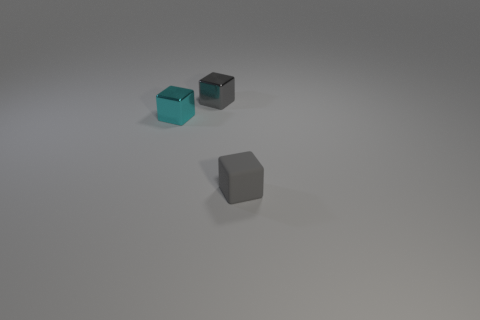There is a small metallic object that is the same color as the tiny matte object; what shape is it?
Ensure brevity in your answer.  Cube. What is the shape of the shiny object that is behind the small cyan thing?
Keep it short and to the point. Cube. What number of tiny cubes are both to the right of the tiny cyan cube and in front of the gray shiny object?
Provide a short and direct response. 1. There is a cyan metal thing; is its size the same as the metal object that is on the right side of the cyan thing?
Your response must be concise. Yes. There is a metallic cube behind the shiny block that is on the left side of the gray cube that is behind the matte object; how big is it?
Your response must be concise. Small. What is the size of the cube in front of the tiny cyan metal block?
Give a very brief answer. Small. There is a gray object that is the same material as the tiny cyan thing; what shape is it?
Your answer should be very brief. Cube. Do the gray thing left of the small matte thing and the small cyan block have the same material?
Ensure brevity in your answer.  Yes. How many other objects are the same material as the tiny cyan object?
Provide a succinct answer. 1. What number of objects are either gray cubes that are in front of the small cyan block or small objects behind the cyan thing?
Your answer should be very brief. 2. 